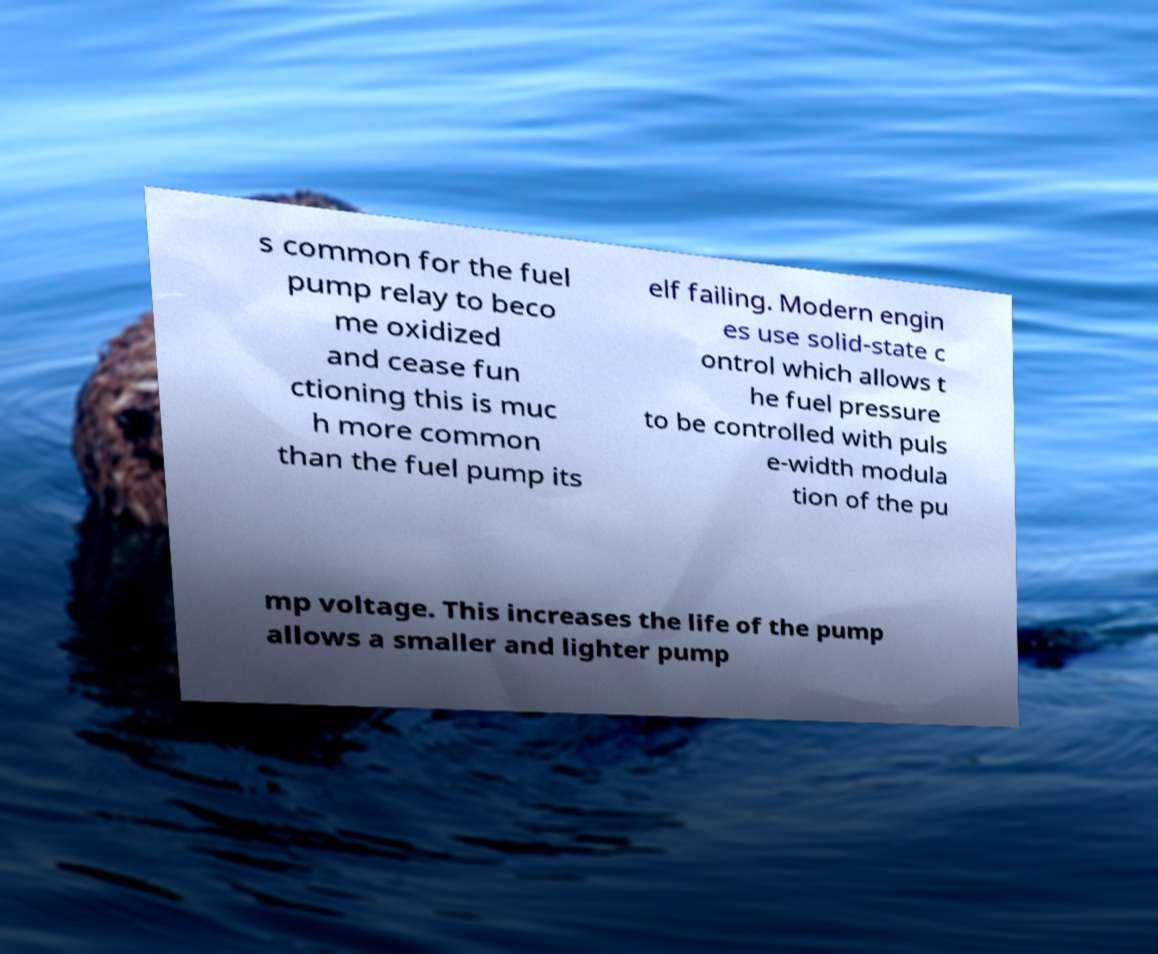I need the written content from this picture converted into text. Can you do that? s common for the fuel pump relay to beco me oxidized and cease fun ctioning this is muc h more common than the fuel pump its elf failing. Modern engin es use solid-state c ontrol which allows t he fuel pressure to be controlled with puls e-width modula tion of the pu mp voltage. This increases the life of the pump allows a smaller and lighter pump 